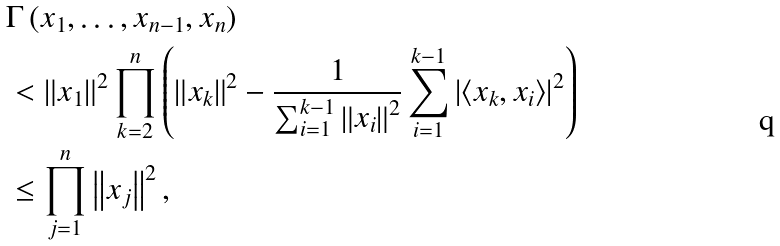<formula> <loc_0><loc_0><loc_500><loc_500>& \Gamma \left ( x _ { 1 } , \dots , x _ { n - 1 } , x _ { n } \right ) \\ & < \left \| x _ { 1 } \right \| ^ { 2 } \prod _ { k = 2 } ^ { n } \left ( \left \| x _ { k } \right \| ^ { 2 } - \frac { 1 } { \sum _ { i = 1 } ^ { k - 1 } \left \| x _ { i } \right \| ^ { 2 } } \sum _ { i = 1 } ^ { k - 1 } \left | \left \langle x _ { k } , x _ { i } \right \rangle \right | ^ { 2 } \right ) \\ & \leq \prod _ { j = 1 } ^ { n } \left \| x _ { j } \right \| ^ { 2 } ,</formula> 